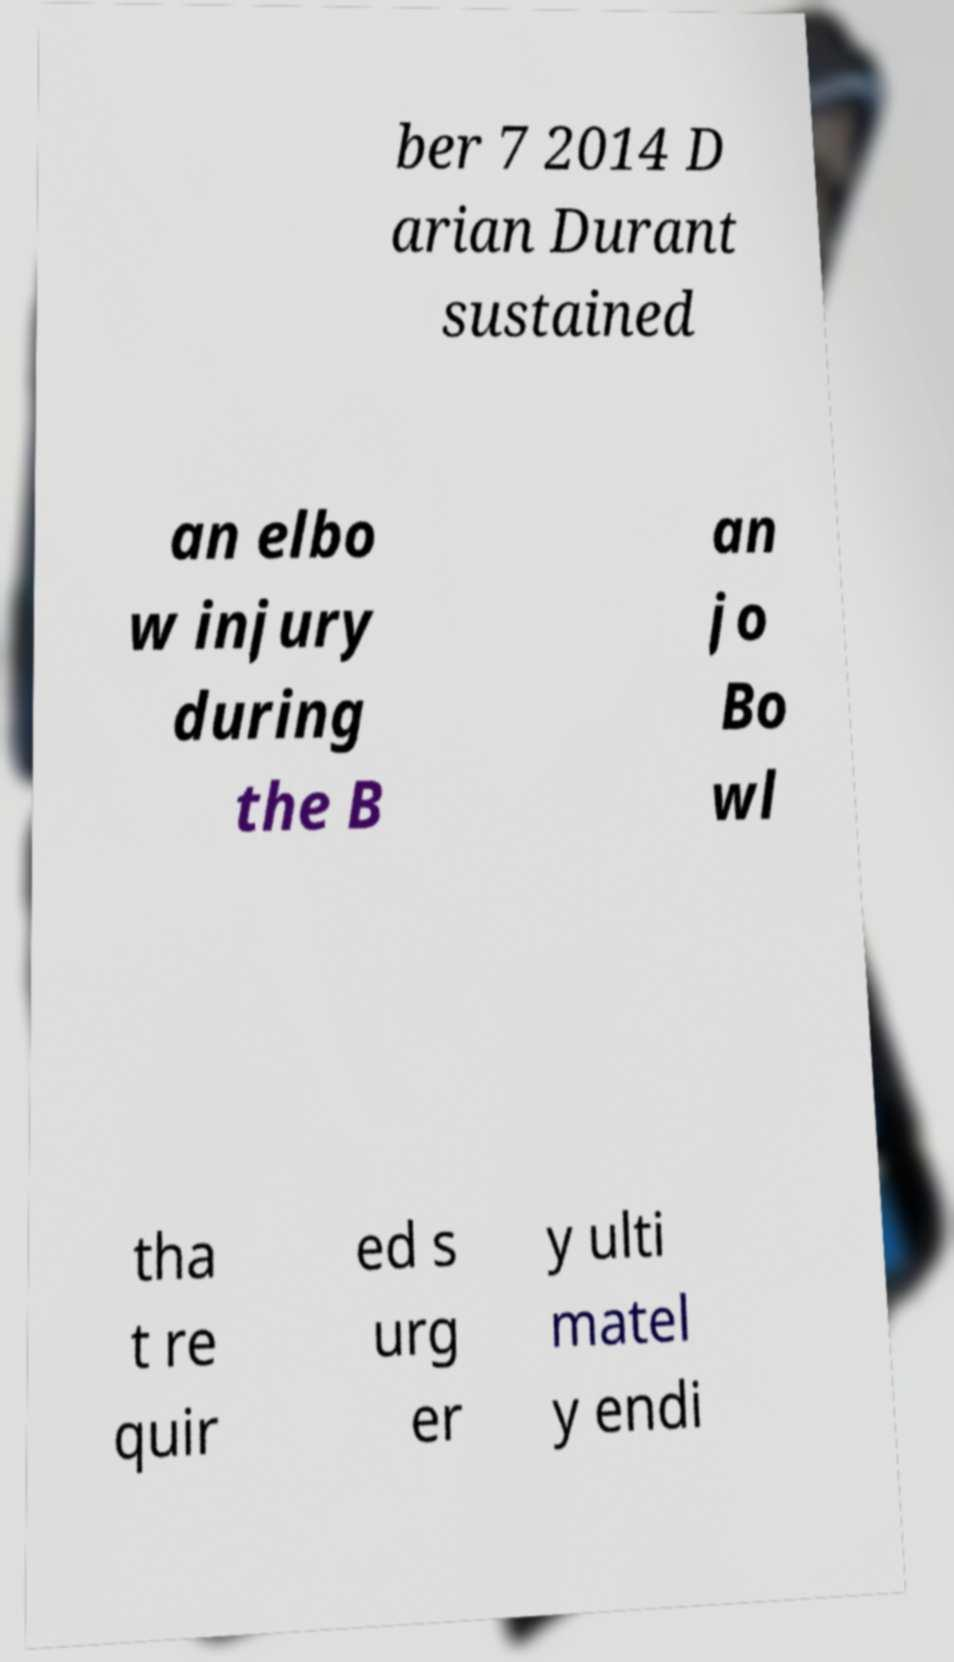Can you accurately transcribe the text from the provided image for me? ber 7 2014 D arian Durant sustained an elbo w injury during the B an jo Bo wl tha t re quir ed s urg er y ulti matel y endi 